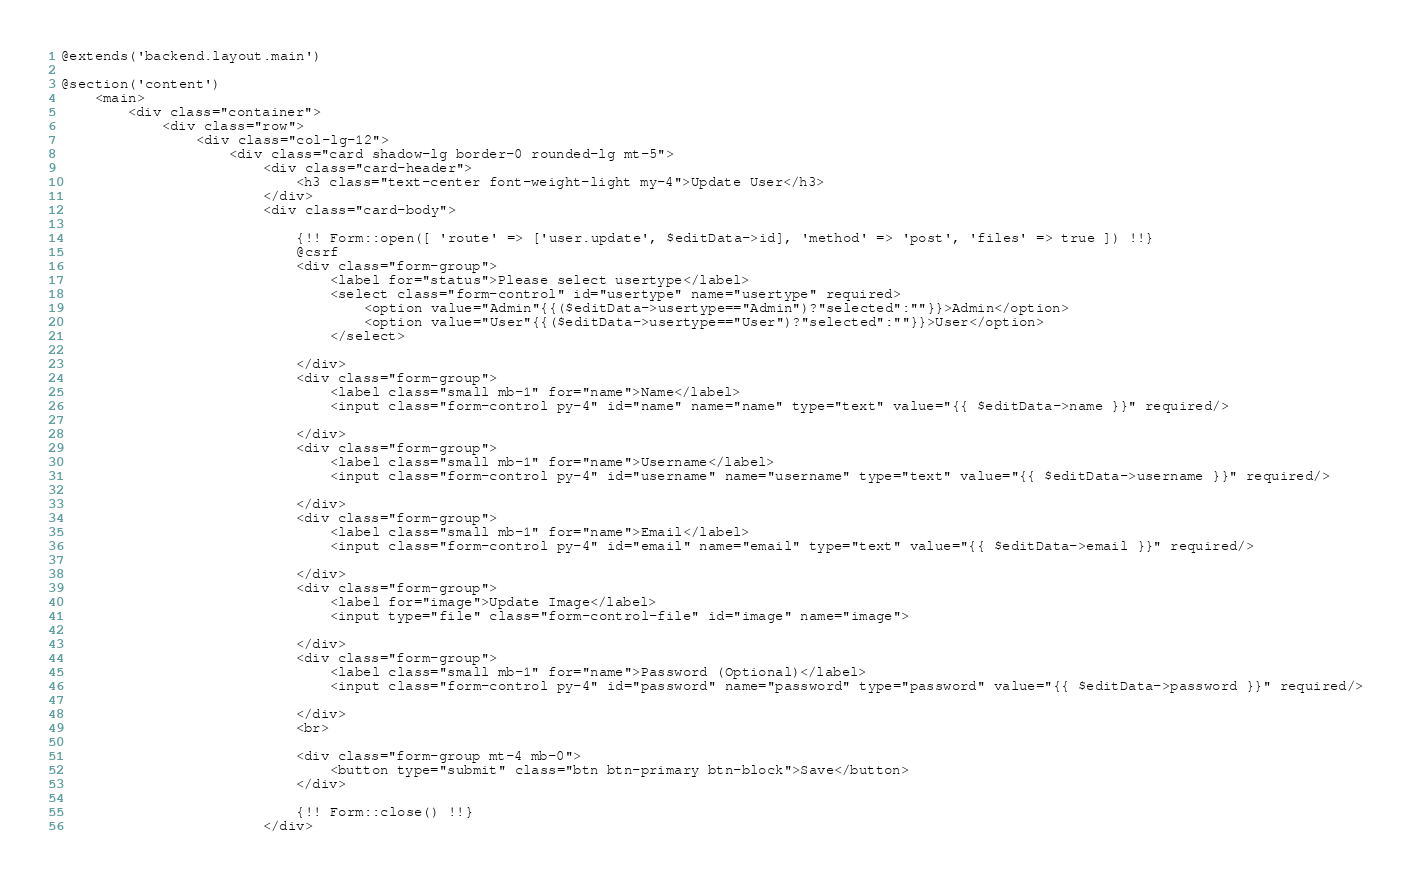<code> <loc_0><loc_0><loc_500><loc_500><_PHP_>@extends('backend.layout.main')

@section('content')
    <main>
        <div class="container">
            <div class="row">
                <div class="col-lg-12">
                    <div class="card shadow-lg border-0 rounded-lg mt-5">
                        <div class="card-header">
                            <h3 class="text-center font-weight-light my-4">Update User</h3>
                        </div>
                        <div class="card-body">

                            {!! Form::open([ 'route' => ['user.update', $editData->id], 'method' => 'post', 'files' => true ]) !!}
                            @csrf
                            <div class="form-group">
                                <label for="status">Please select usertype</label>
                                <select class="form-control" id="usertype" name="usertype" required>
                                    <option value="Admin"{{($editData->usertype=="Admin")?"selected":""}}>Admin</option>
                                    <option value="User"{{($editData->usertype=="User")?"selected":""}}>User</option>
                                </select>

                            </div>
                            <div class="form-group">
                                <label class="small mb-1" for="name">Name</label>
                                <input class="form-control py-4" id="name" name="name" type="text" value="{{ $editData->name }}" required/>

                            </div>
                            <div class="form-group">
                                <label class="small mb-1" for="name">Username</label>
                                <input class="form-control py-4" id="username" name="username" type="text" value="{{ $editData->username }}" required/>

                            </div>
                            <div class="form-group">
                                <label class="small mb-1" for="name">Email</label>
                                <input class="form-control py-4" id="email" name="email" type="text" value="{{ $editData->email }}" required/>

                            </div>
                            <div class="form-group">
                                <label for="image">Update Image</label>
                                <input type="file" class="form-control-file" id="image" name="image">

                            </div>
                            <div class="form-group">
                                <label class="small mb-1" for="name">Password (Optional)</label>
                                <input class="form-control py-4" id="password" name="password" type="password" value="{{ $editData->password }}" required/>

                            </div>
                            <br>

                            <div class="form-group mt-4 mb-0">
                                <button type="submit" class="btn btn-primary btn-block">Save</button>
                            </div>

                            {!! Form::close() !!}
                        </div>
</code> 